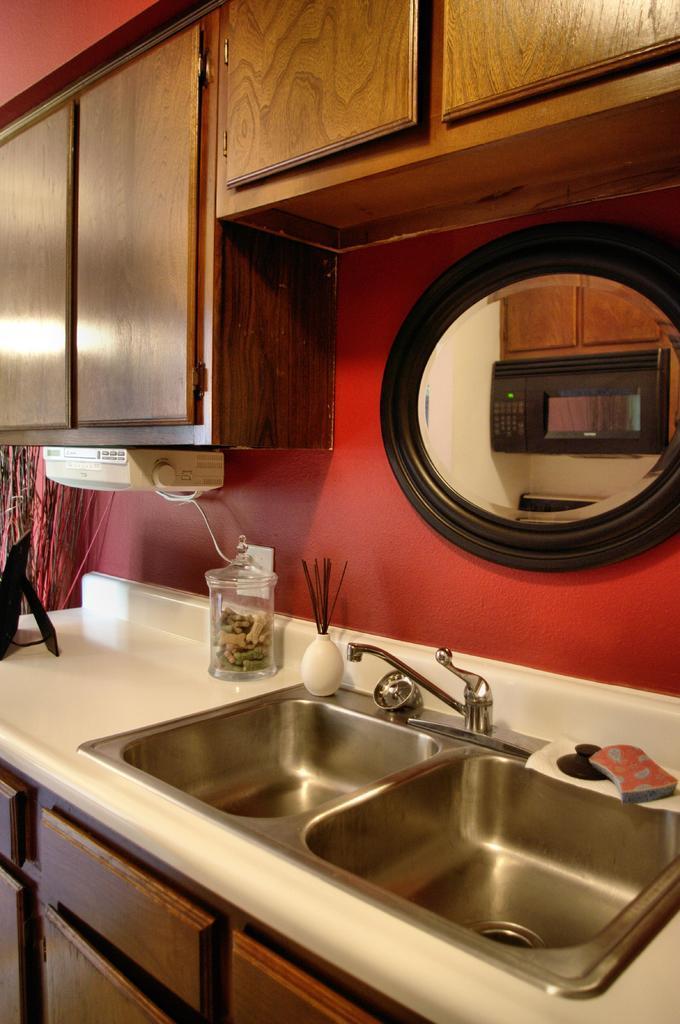How would you summarize this image in a sentence or two? In this image I can see sinks and a tap. I can also see some other objects on a white color surface. Here I can see wooden objects. 